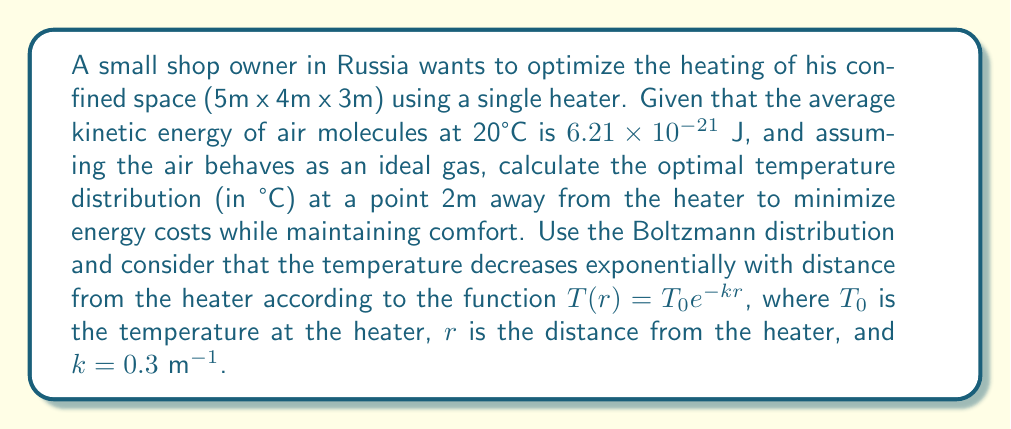Provide a solution to this math problem. To solve this problem, we'll follow these steps:

1) First, we need to determine the temperature at the heater ($T_0$). We know that at 20°C (293.15 K), the average kinetic energy is $6.21 \times 10^{-21}$ J. Using the equipartition theorem:

   $$\frac{3}{2}kT = 6.21 \times 10^{-21} \text{ J}$$

   Where $k$ is the Boltzmann constant ($1.38 \times 10^{-23}$ J/K).

2) Solving for T:

   $$T = \frac{2(6.21 \times 10^{-21})}{3(1.38 \times 10^{-23})} = 300 \text{ K}$$

   This corresponds to about 27°C, which we'll use as our $T_0$.

3) Now, we can use the given temperature distribution function:

   $$T(r) = T_0 e^{-kr}$$

   Where $T_0 = 300$ K, $k = 0.3$ m^(-1), and $r = 2$ m.

4) Plugging in these values:

   $$T(2) = 300 e^{-0.3 \times 2} = 300 e^{-0.6} = 300 \times 0.5488 = 164.64 \text{ K}$$

5) Converting from Kelvin to Celsius:

   $$164.64 \text{ K} - 273.15 = -108.51°C$$

This temperature is far too cold for comfort. To optimize for both energy costs and comfort, we should aim for a temperature around 20°C at this distance.

6) Let's solve for the required $T_0$ to achieve 20°C (293.15 K) at 2m:

   $$293.15 = T_0 e^{-0.3 \times 2}$$
   $$293.15 = T_0 \times 0.5488$$
   $$T_0 = 293.15 / 0.5488 = 534.17 \text{ K}$$

7) Converting to Celsius:

   $$534.17 \text{ K} - 273.15 = 261.02°C$$

Therefore, the heater should be set to approximately 261°C to achieve an optimal temperature of 20°C at a distance of 2m.
Answer: 261°C at the heater to achieve 20°C at 2m distance 